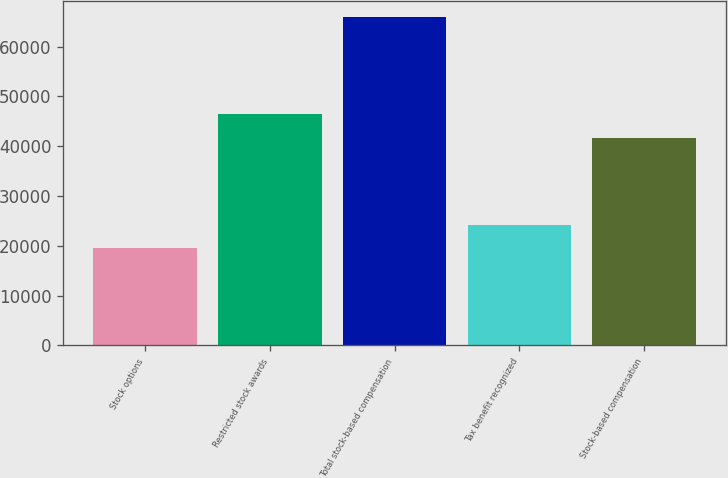Convert chart. <chart><loc_0><loc_0><loc_500><loc_500><bar_chart><fcel>Stock options<fcel>Restricted stock awards<fcel>Total stock-based compensation<fcel>Tax benefit recognized<fcel>Stock-based compensation<nl><fcel>19555<fcel>46373.5<fcel>65870<fcel>24186.5<fcel>41742<nl></chart> 